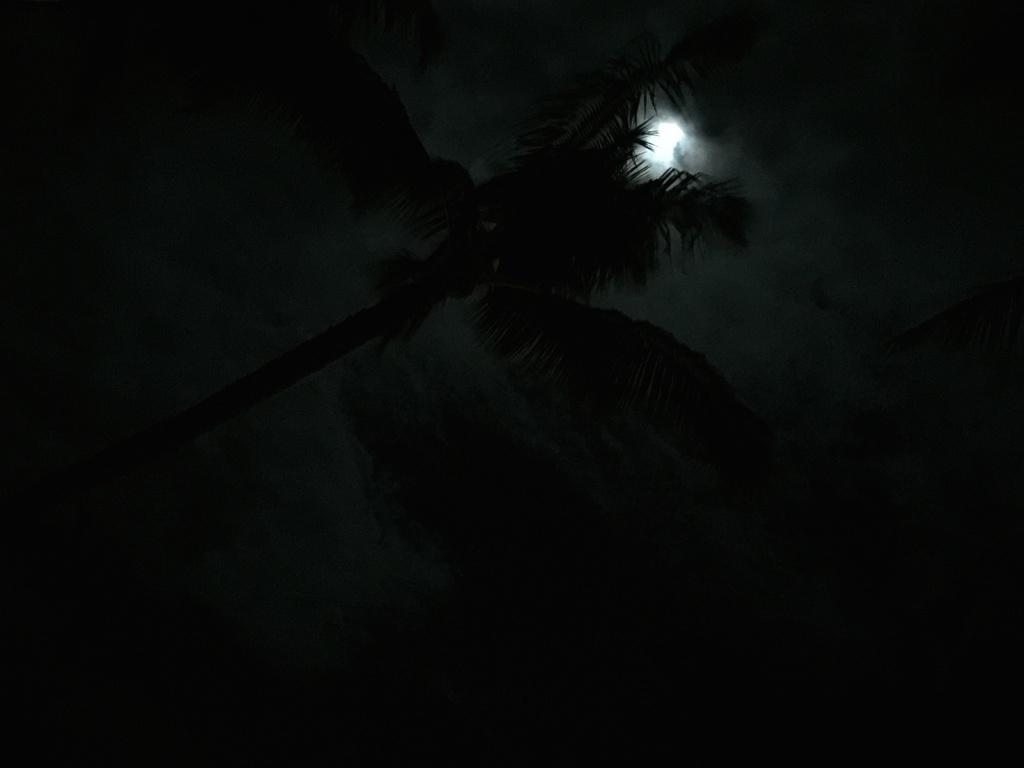Can you describe this image briefly? In this picture we can see a tree on the left side. We can see the moon in the sky. There is the dark view in the background. 